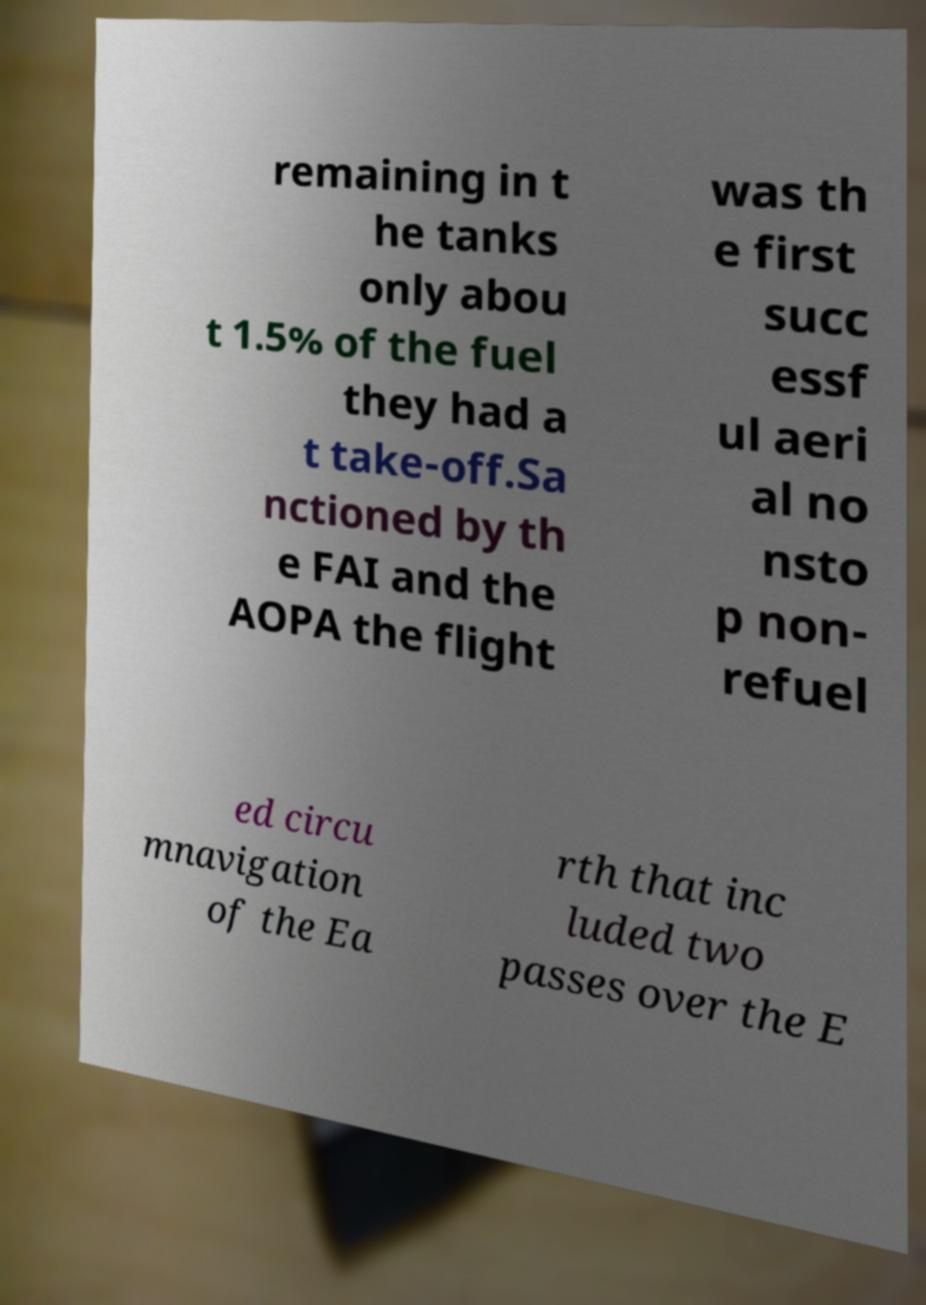What messages or text are displayed in this image? I need them in a readable, typed format. remaining in t he tanks only abou t 1.5% of the fuel they had a t take-off.Sa nctioned by th e FAI and the AOPA the flight was th e first succ essf ul aeri al no nsto p non- refuel ed circu mnavigation of the Ea rth that inc luded two passes over the E 